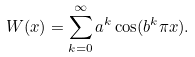<formula> <loc_0><loc_0><loc_500><loc_500>W ( x ) = \sum _ { k = 0 } ^ { \infty } a ^ { k } \cos ( b ^ { k } \pi x ) .</formula> 